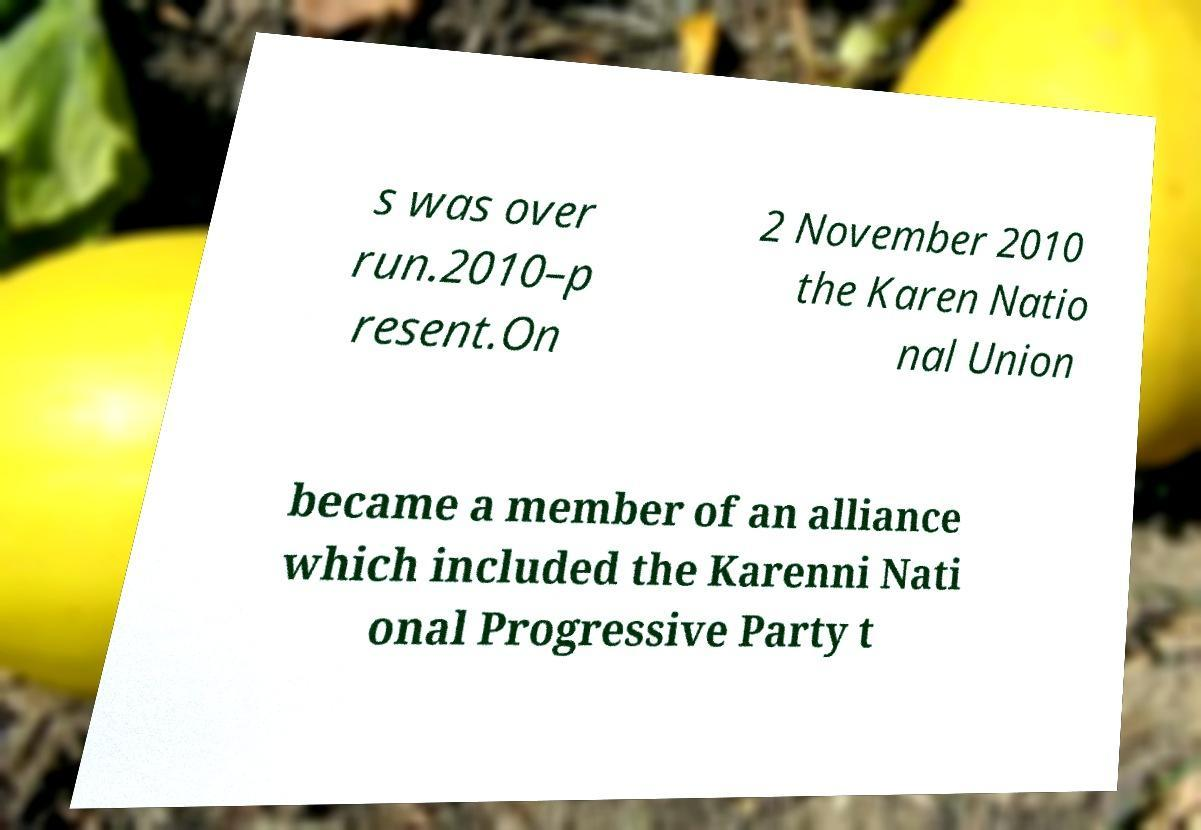Can you accurately transcribe the text from the provided image for me? s was over run.2010–p resent.On 2 November 2010 the Karen Natio nal Union became a member of an alliance which included the Karenni Nati onal Progressive Party t 